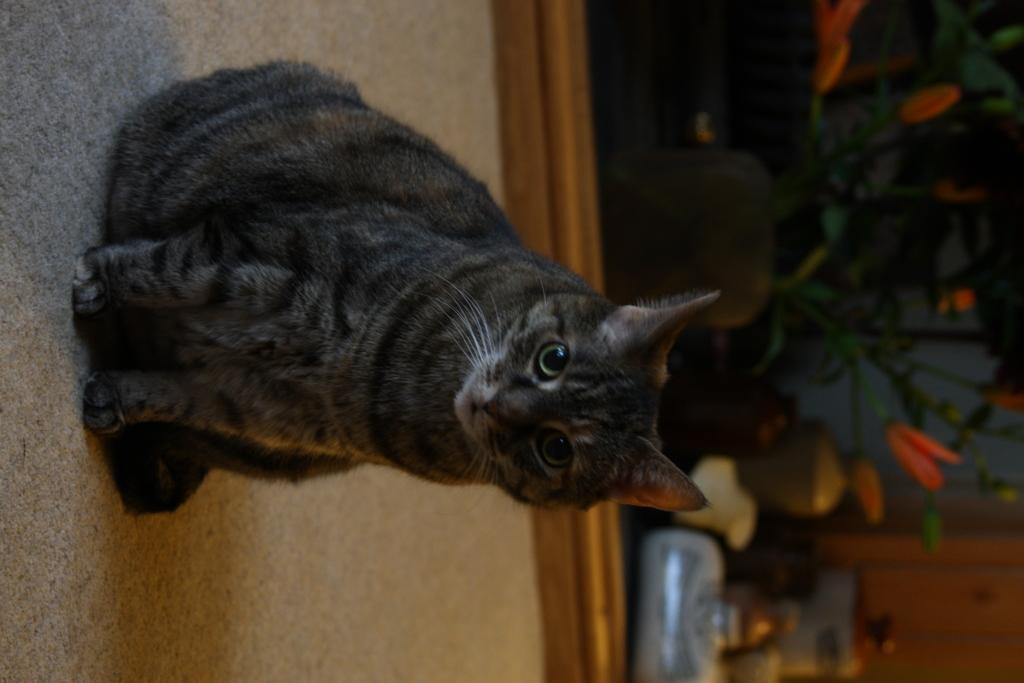How would you summarize this image in a sentence or two? In the picture I can see a cat is sitting on the floor. In the background I can see a plant pot and some other objects. The background of the image is blurred. 